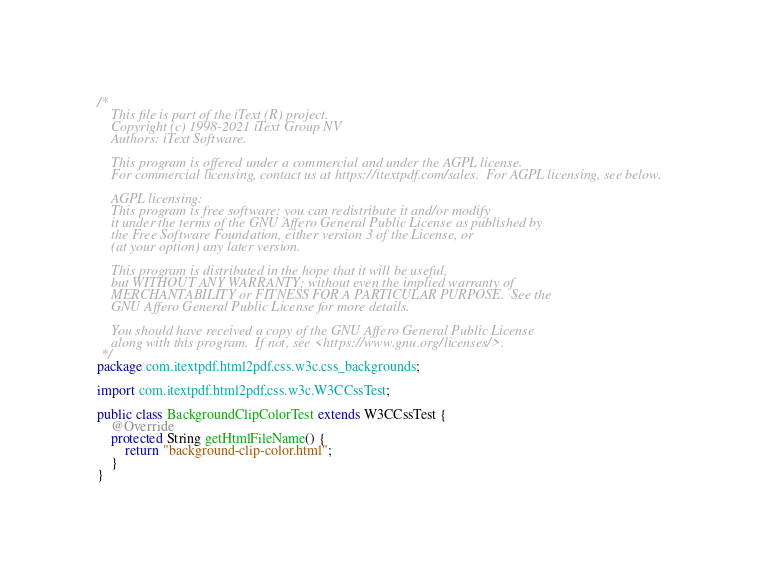<code> <loc_0><loc_0><loc_500><loc_500><_Java_>/*
    This file is part of the iText (R) project.
    Copyright (c) 1998-2021 iText Group NV
    Authors: iText Software.

    This program is offered under a commercial and under the AGPL license.
    For commercial licensing, contact us at https://itextpdf.com/sales.  For AGPL licensing, see below.

    AGPL licensing:
    This program is free software: you can redistribute it and/or modify
    it under the terms of the GNU Affero General Public License as published by
    the Free Software Foundation, either version 3 of the License, or
    (at your option) any later version.

    This program is distributed in the hope that it will be useful,
    but WITHOUT ANY WARRANTY; without even the implied warranty of
    MERCHANTABILITY or FITNESS FOR A PARTICULAR PURPOSE.  See the
    GNU Affero General Public License for more details.

    You should have received a copy of the GNU Affero General Public License
    along with this program.  If not, see <https://www.gnu.org/licenses/>.
 */
package com.itextpdf.html2pdf.css.w3c.css_backgrounds;

import com.itextpdf.html2pdf.css.w3c.W3CCssTest;

public class BackgroundClipColorTest extends W3CCssTest {
    @Override
    protected String getHtmlFileName() {
        return "background-clip-color.html";
    }
}
</code> 